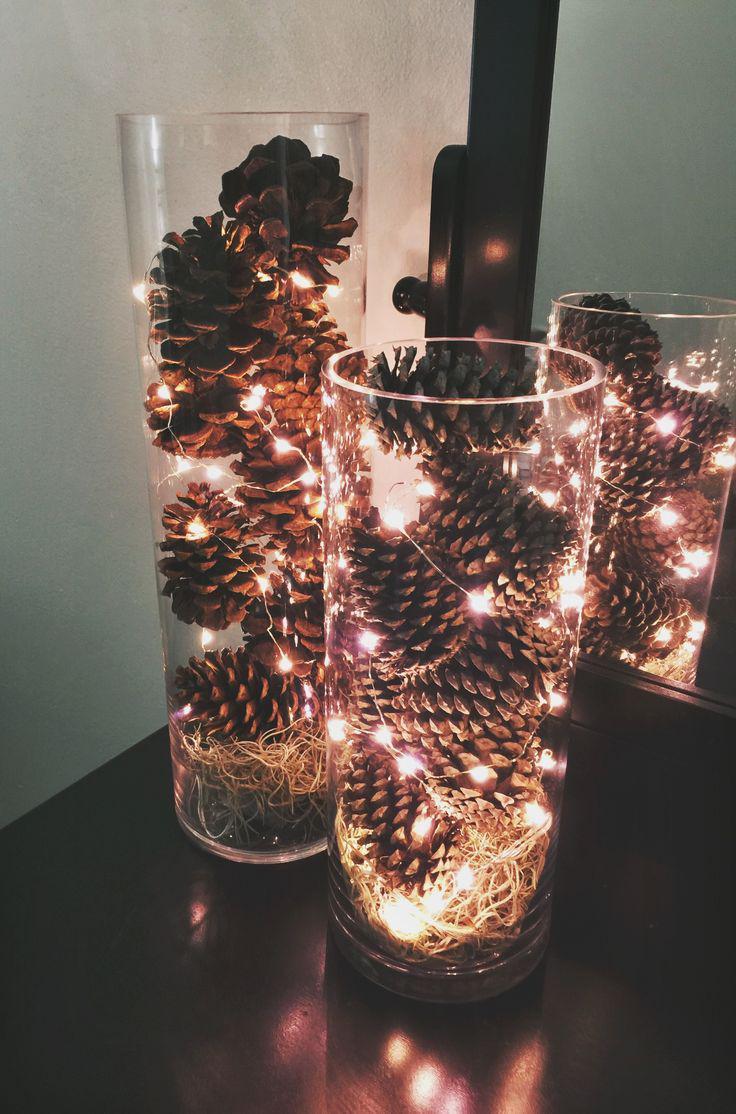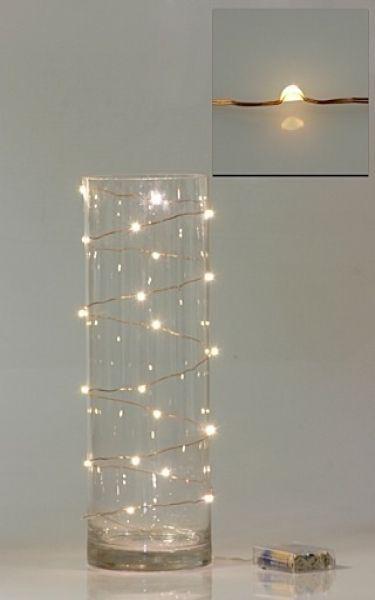The first image is the image on the left, the second image is the image on the right. Evaluate the accuracy of this statement regarding the images: "There are pine cones in at least one clear glass vase with stringed lights inside with them.". Is it true? Answer yes or no. Yes. The first image is the image on the left, the second image is the image on the right. For the images shown, is this caption "At least 1 glass container is decorated with pine cones and lights." true? Answer yes or no. Yes. 